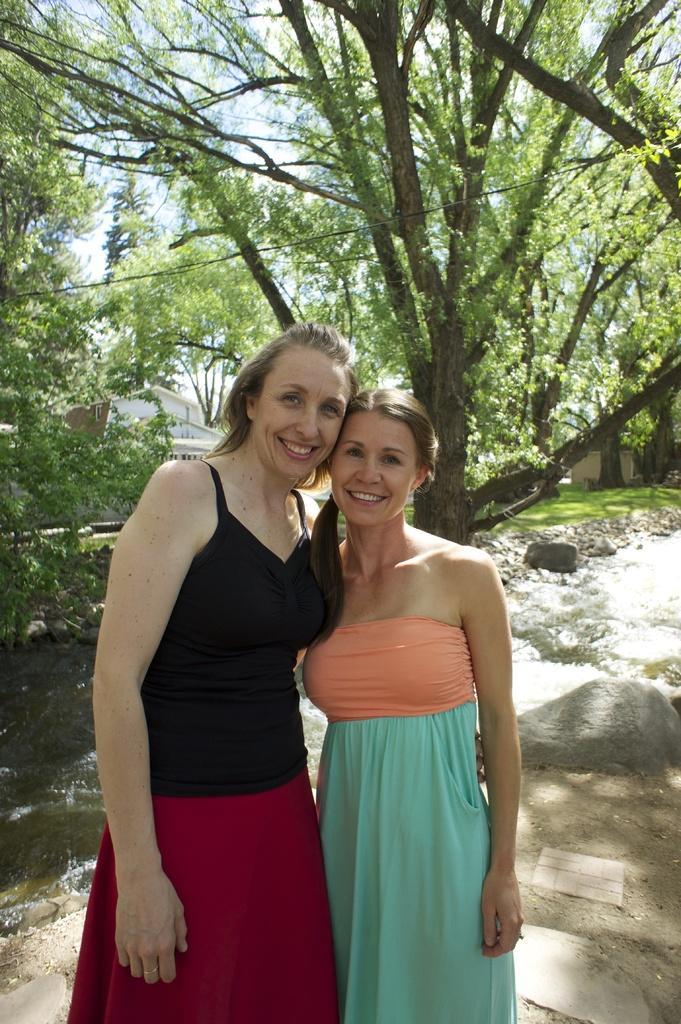Please provide a concise description of this image. In this image I can see two persons standing. The person at right is wearing orange and green color dress and the person at left is wearing black and maroon color dress. In the background I can see few trees in green color and the sky is in blue and white color. 